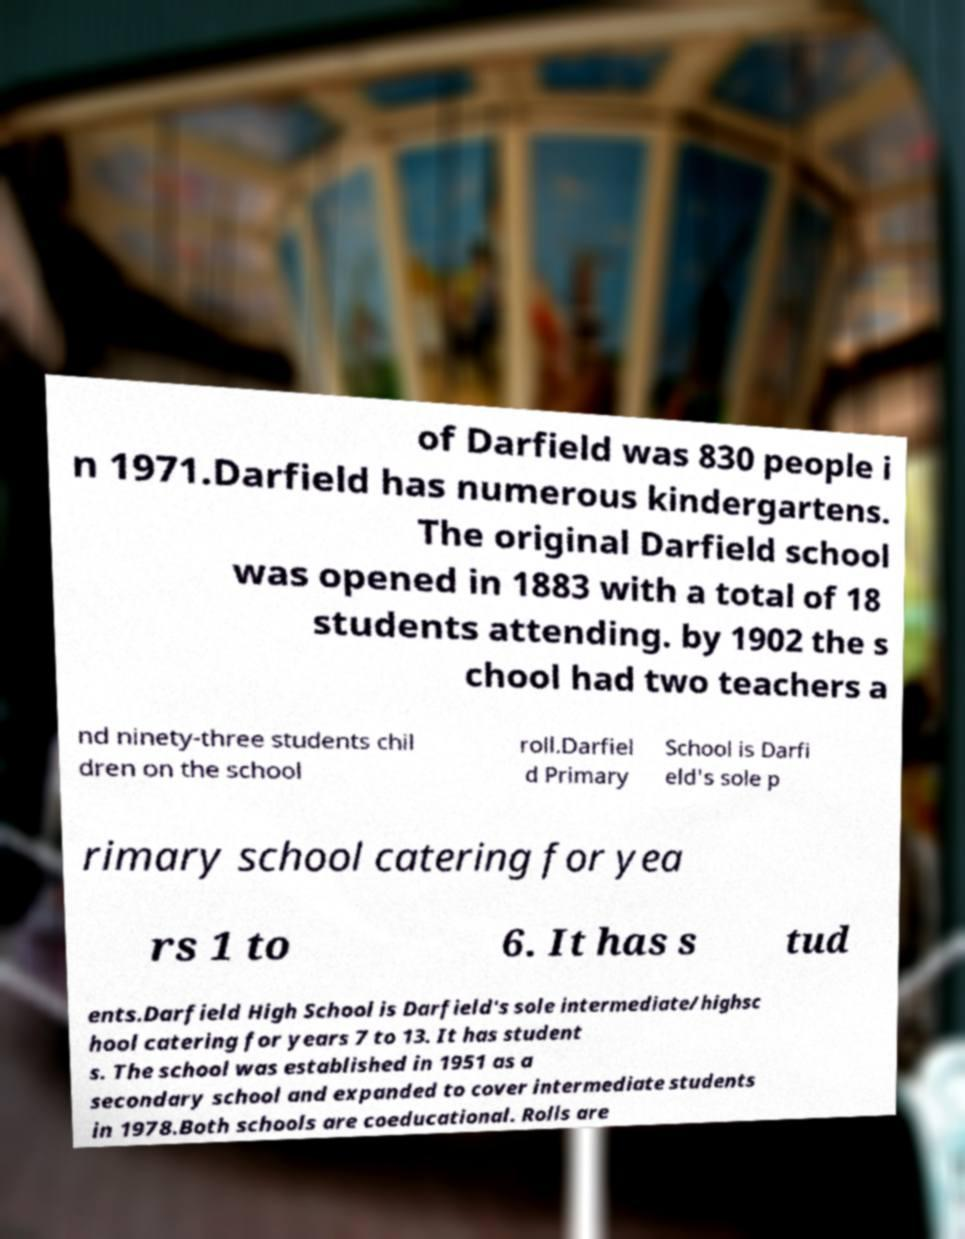Please read and relay the text visible in this image. What does it say? of Darfield was 830 people i n 1971.Darfield has numerous kindergartens. The original Darfield school was opened in 1883 with a total of 18 students attending. by 1902 the s chool had two teachers a nd ninety-three students chil dren on the school roll.Darfiel d Primary School is Darfi eld's sole p rimary school catering for yea rs 1 to 6. It has s tud ents.Darfield High School is Darfield's sole intermediate/highsc hool catering for years 7 to 13. It has student s. The school was established in 1951 as a secondary school and expanded to cover intermediate students in 1978.Both schools are coeducational. Rolls are 